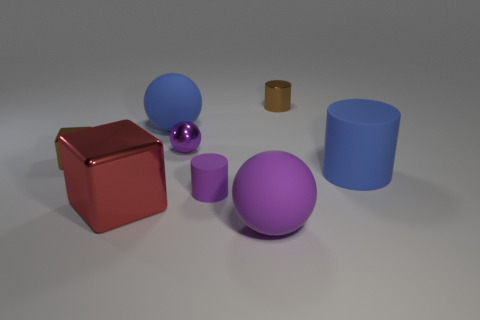There is a big rubber object in front of the blue cylinder; is it the same shape as the purple metallic object?
Your answer should be compact. Yes. There is another ball that is the same color as the small shiny sphere; what is its size?
Your response must be concise. Large. What number of red objects are tiny matte cylinders or rubber objects?
Offer a terse response. 0. How many other objects are there of the same shape as the large red thing?
Provide a short and direct response. 1. What shape is the large matte thing that is left of the tiny brown shiny cylinder and behind the purple matte sphere?
Give a very brief answer. Sphere. There is a large matte cylinder; are there any brown blocks behind it?
Give a very brief answer. Yes. There is another object that is the same shape as the big metal thing; what is its size?
Your response must be concise. Small. Does the tiny purple metal object have the same shape as the big purple rubber object?
Give a very brief answer. Yes. How big is the blue thing that is in front of the tiny brown object on the left side of the large red cube?
Provide a succinct answer. Large. What is the color of the tiny object that is the same shape as the large shiny thing?
Your answer should be very brief. Brown. 